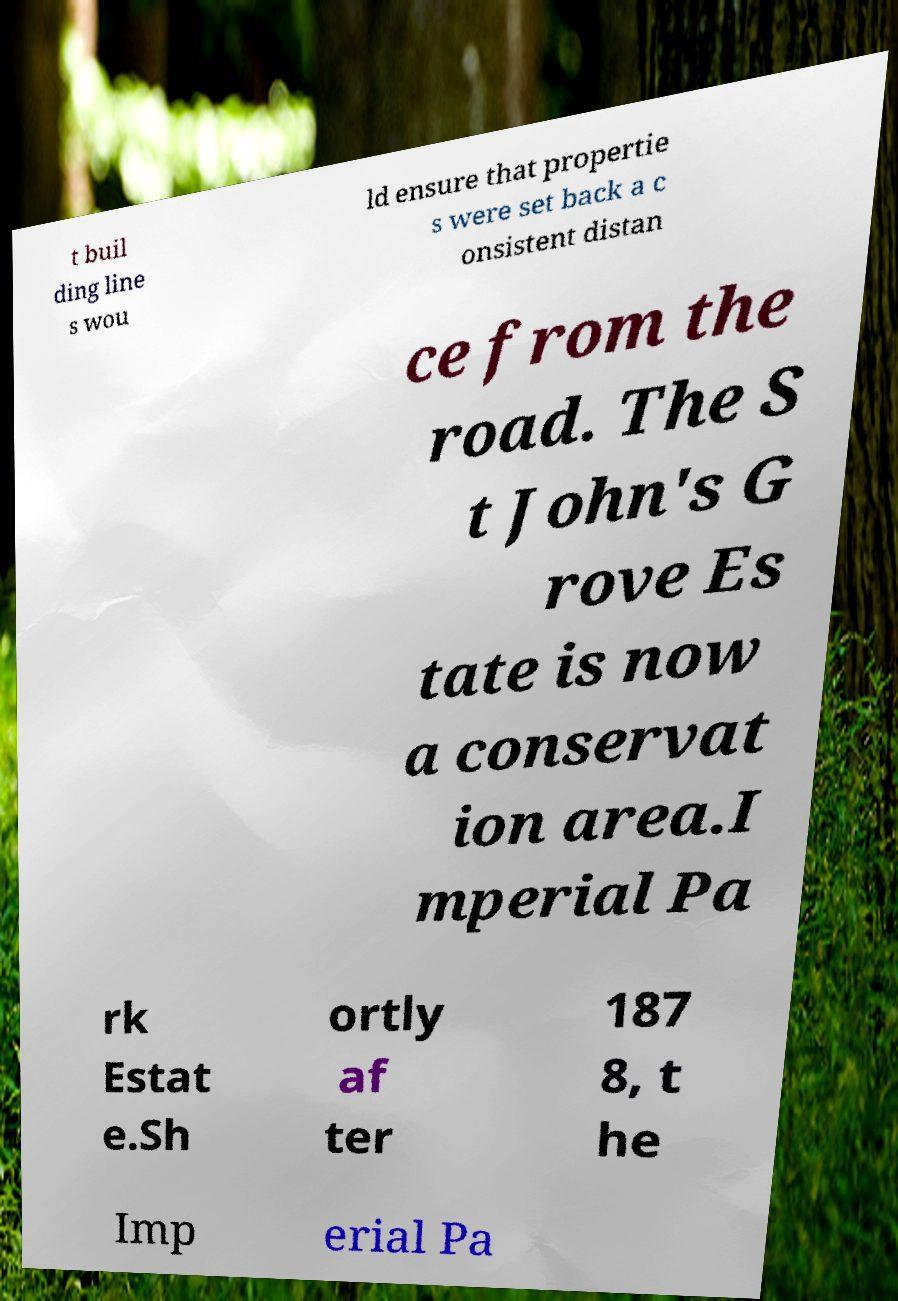There's text embedded in this image that I need extracted. Can you transcribe it verbatim? t buil ding line s wou ld ensure that propertie s were set back a c onsistent distan ce from the road. The S t John's G rove Es tate is now a conservat ion area.I mperial Pa rk Estat e.Sh ortly af ter 187 8, t he Imp erial Pa 